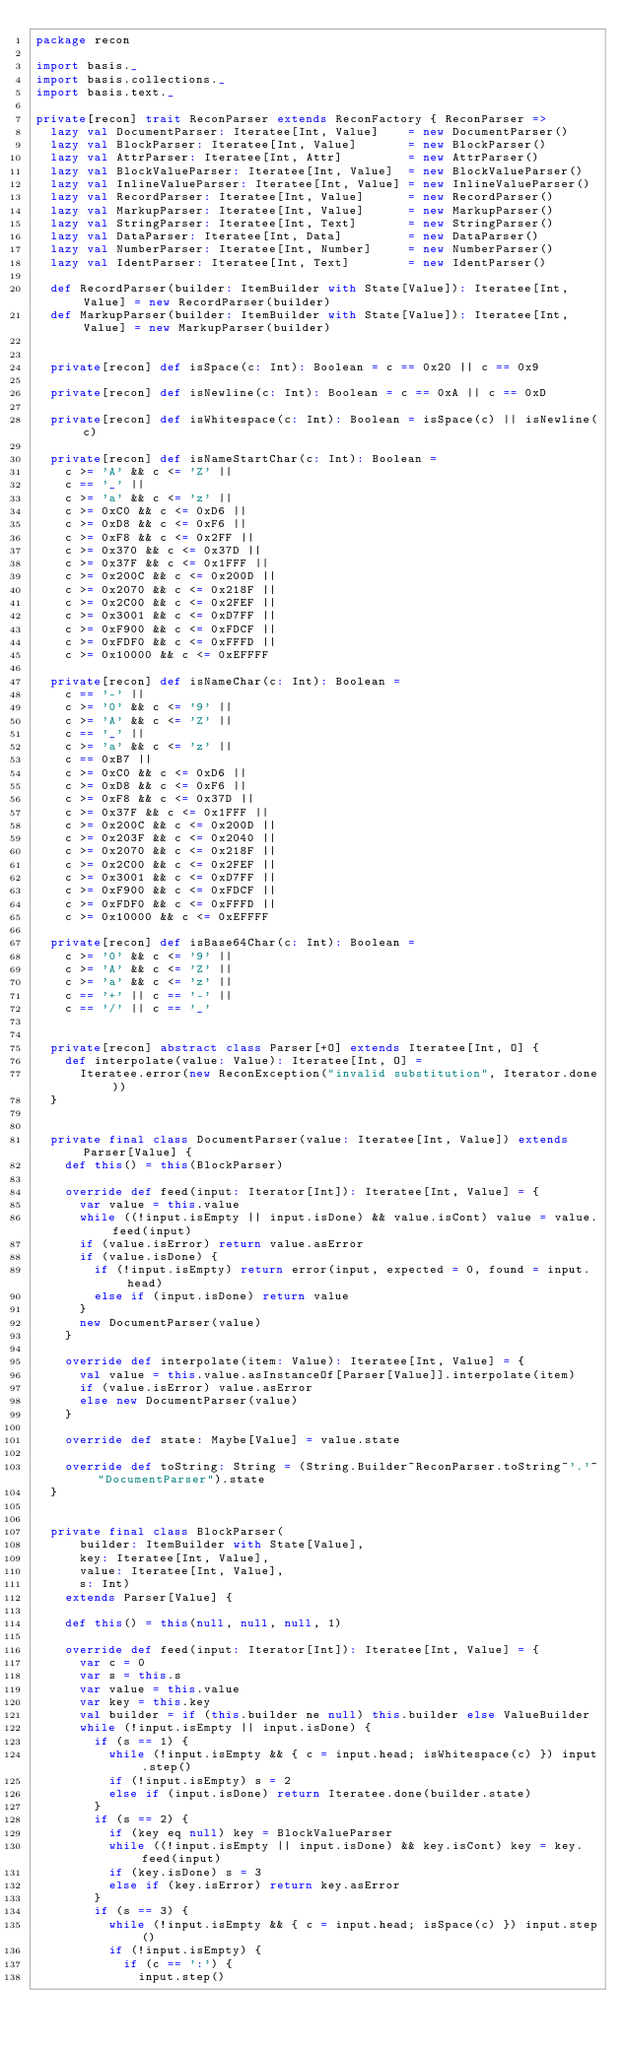Convert code to text. <code><loc_0><loc_0><loc_500><loc_500><_Scala_>package recon

import basis._
import basis.collections._
import basis.text._

private[recon] trait ReconParser extends ReconFactory { ReconParser =>
  lazy val DocumentParser: Iteratee[Int, Value]    = new DocumentParser()
  lazy val BlockParser: Iteratee[Int, Value]       = new BlockParser()
  lazy val AttrParser: Iteratee[Int, Attr]         = new AttrParser()
  lazy val BlockValueParser: Iteratee[Int, Value]  = new BlockValueParser()
  lazy val InlineValueParser: Iteratee[Int, Value] = new InlineValueParser()
  lazy val RecordParser: Iteratee[Int, Value]      = new RecordParser()
  lazy val MarkupParser: Iteratee[Int, Value]      = new MarkupParser()
  lazy val StringParser: Iteratee[Int, Text]       = new StringParser()
  lazy val DataParser: Iteratee[Int, Data]         = new DataParser()
  lazy val NumberParser: Iteratee[Int, Number]     = new NumberParser()
  lazy val IdentParser: Iteratee[Int, Text]        = new IdentParser()

  def RecordParser(builder: ItemBuilder with State[Value]): Iteratee[Int, Value] = new RecordParser(builder)
  def MarkupParser(builder: ItemBuilder with State[Value]): Iteratee[Int, Value] = new MarkupParser(builder)


  private[recon] def isSpace(c: Int): Boolean = c == 0x20 || c == 0x9

  private[recon] def isNewline(c: Int): Boolean = c == 0xA || c == 0xD

  private[recon] def isWhitespace(c: Int): Boolean = isSpace(c) || isNewline(c)

  private[recon] def isNameStartChar(c: Int): Boolean =
    c >= 'A' && c <= 'Z' ||
    c == '_' ||
    c >= 'a' && c <= 'z' ||
    c >= 0xC0 && c <= 0xD6 ||
    c >= 0xD8 && c <= 0xF6 ||
    c >= 0xF8 && c <= 0x2FF ||
    c >= 0x370 && c <= 0x37D ||
    c >= 0x37F && c <= 0x1FFF ||
    c >= 0x200C && c <= 0x200D ||
    c >= 0x2070 && c <= 0x218F ||
    c >= 0x2C00 && c <= 0x2FEF ||
    c >= 0x3001 && c <= 0xD7FF ||
    c >= 0xF900 && c <= 0xFDCF ||
    c >= 0xFDF0 && c <= 0xFFFD ||
    c >= 0x10000 && c <= 0xEFFFF

  private[recon] def isNameChar(c: Int): Boolean =
    c == '-' ||
    c >= '0' && c <= '9' ||
    c >= 'A' && c <= 'Z' ||
    c == '_' ||
    c >= 'a' && c <= 'z' ||
    c == 0xB7 ||
    c >= 0xC0 && c <= 0xD6 ||
    c >= 0xD8 && c <= 0xF6 ||
    c >= 0xF8 && c <= 0x37D ||
    c >= 0x37F && c <= 0x1FFF ||
    c >= 0x200C && c <= 0x200D ||
    c >= 0x203F && c <= 0x2040 ||
    c >= 0x2070 && c <= 0x218F ||
    c >= 0x2C00 && c <= 0x2FEF ||
    c >= 0x3001 && c <= 0xD7FF ||
    c >= 0xF900 && c <= 0xFDCF ||
    c >= 0xFDF0 && c <= 0xFFFD ||
    c >= 0x10000 && c <= 0xEFFFF

  private[recon] def isBase64Char(c: Int): Boolean =
    c >= '0' && c <= '9' ||
    c >= 'A' && c <= 'Z' ||
    c >= 'a' && c <= 'z' ||
    c == '+' || c == '-' ||
    c == '/' || c == '_'


  private[recon] abstract class Parser[+O] extends Iteratee[Int, O] {
    def interpolate(value: Value): Iteratee[Int, O] =
      Iteratee.error(new ReconException("invalid substitution", Iterator.done))
  }


  private final class DocumentParser(value: Iteratee[Int, Value]) extends Parser[Value] {
    def this() = this(BlockParser)

    override def feed(input: Iterator[Int]): Iteratee[Int, Value] = {
      var value = this.value
      while ((!input.isEmpty || input.isDone) && value.isCont) value = value.feed(input)
      if (value.isError) return value.asError
      if (value.isDone) {
        if (!input.isEmpty) return error(input, expected = 0, found = input.head)
        else if (input.isDone) return value
      }
      new DocumentParser(value)
    }

    override def interpolate(item: Value): Iteratee[Int, Value] = {
      val value = this.value.asInstanceOf[Parser[Value]].interpolate(item)
      if (value.isError) value.asError
      else new DocumentParser(value)
    }

    override def state: Maybe[Value] = value.state

    override def toString: String = (String.Builder~ReconParser.toString~'.'~"DocumentParser").state
  }


  private final class BlockParser(
      builder: ItemBuilder with State[Value],
      key: Iteratee[Int, Value],
      value: Iteratee[Int, Value],
      s: Int)
    extends Parser[Value] {

    def this() = this(null, null, null, 1)

    override def feed(input: Iterator[Int]): Iteratee[Int, Value] = {
      var c = 0
      var s = this.s
      var value = this.value
      var key = this.key
      val builder = if (this.builder ne null) this.builder else ValueBuilder
      while (!input.isEmpty || input.isDone) {
        if (s == 1) {
          while (!input.isEmpty && { c = input.head; isWhitespace(c) }) input.step()
          if (!input.isEmpty) s = 2
          else if (input.isDone) return Iteratee.done(builder.state)
        }
        if (s == 2) {
          if (key eq null) key = BlockValueParser
          while ((!input.isEmpty || input.isDone) && key.isCont) key = key.feed(input)
          if (key.isDone) s = 3
          else if (key.isError) return key.asError
        }
        if (s == 3) {
          while (!input.isEmpty && { c = input.head; isSpace(c) }) input.step()
          if (!input.isEmpty) {
            if (c == ':') {
              input.step()</code> 